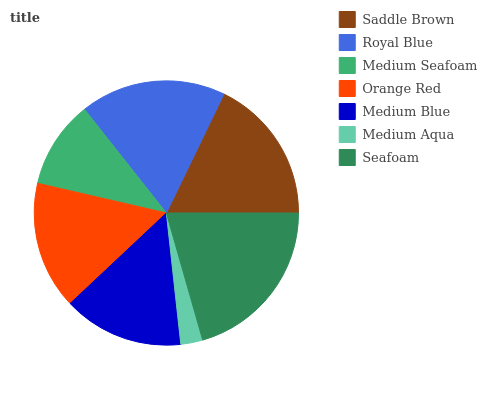Is Medium Aqua the minimum?
Answer yes or no. Yes. Is Seafoam the maximum?
Answer yes or no. Yes. Is Royal Blue the minimum?
Answer yes or no. No. Is Royal Blue the maximum?
Answer yes or no. No. Is Saddle Brown greater than Royal Blue?
Answer yes or no. Yes. Is Royal Blue less than Saddle Brown?
Answer yes or no. Yes. Is Royal Blue greater than Saddle Brown?
Answer yes or no. No. Is Saddle Brown less than Royal Blue?
Answer yes or no. No. Is Orange Red the high median?
Answer yes or no. Yes. Is Orange Red the low median?
Answer yes or no. Yes. Is Medium Blue the high median?
Answer yes or no. No. Is Medium Blue the low median?
Answer yes or no. No. 